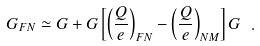Convert formula to latex. <formula><loc_0><loc_0><loc_500><loc_500>G _ { F N } \simeq G + G \left [ \left ( \frac { Q } { e } \right ) _ { F N } - \left ( \frac { Q } { e } \right ) _ { N M } \right ] G \ .</formula> 